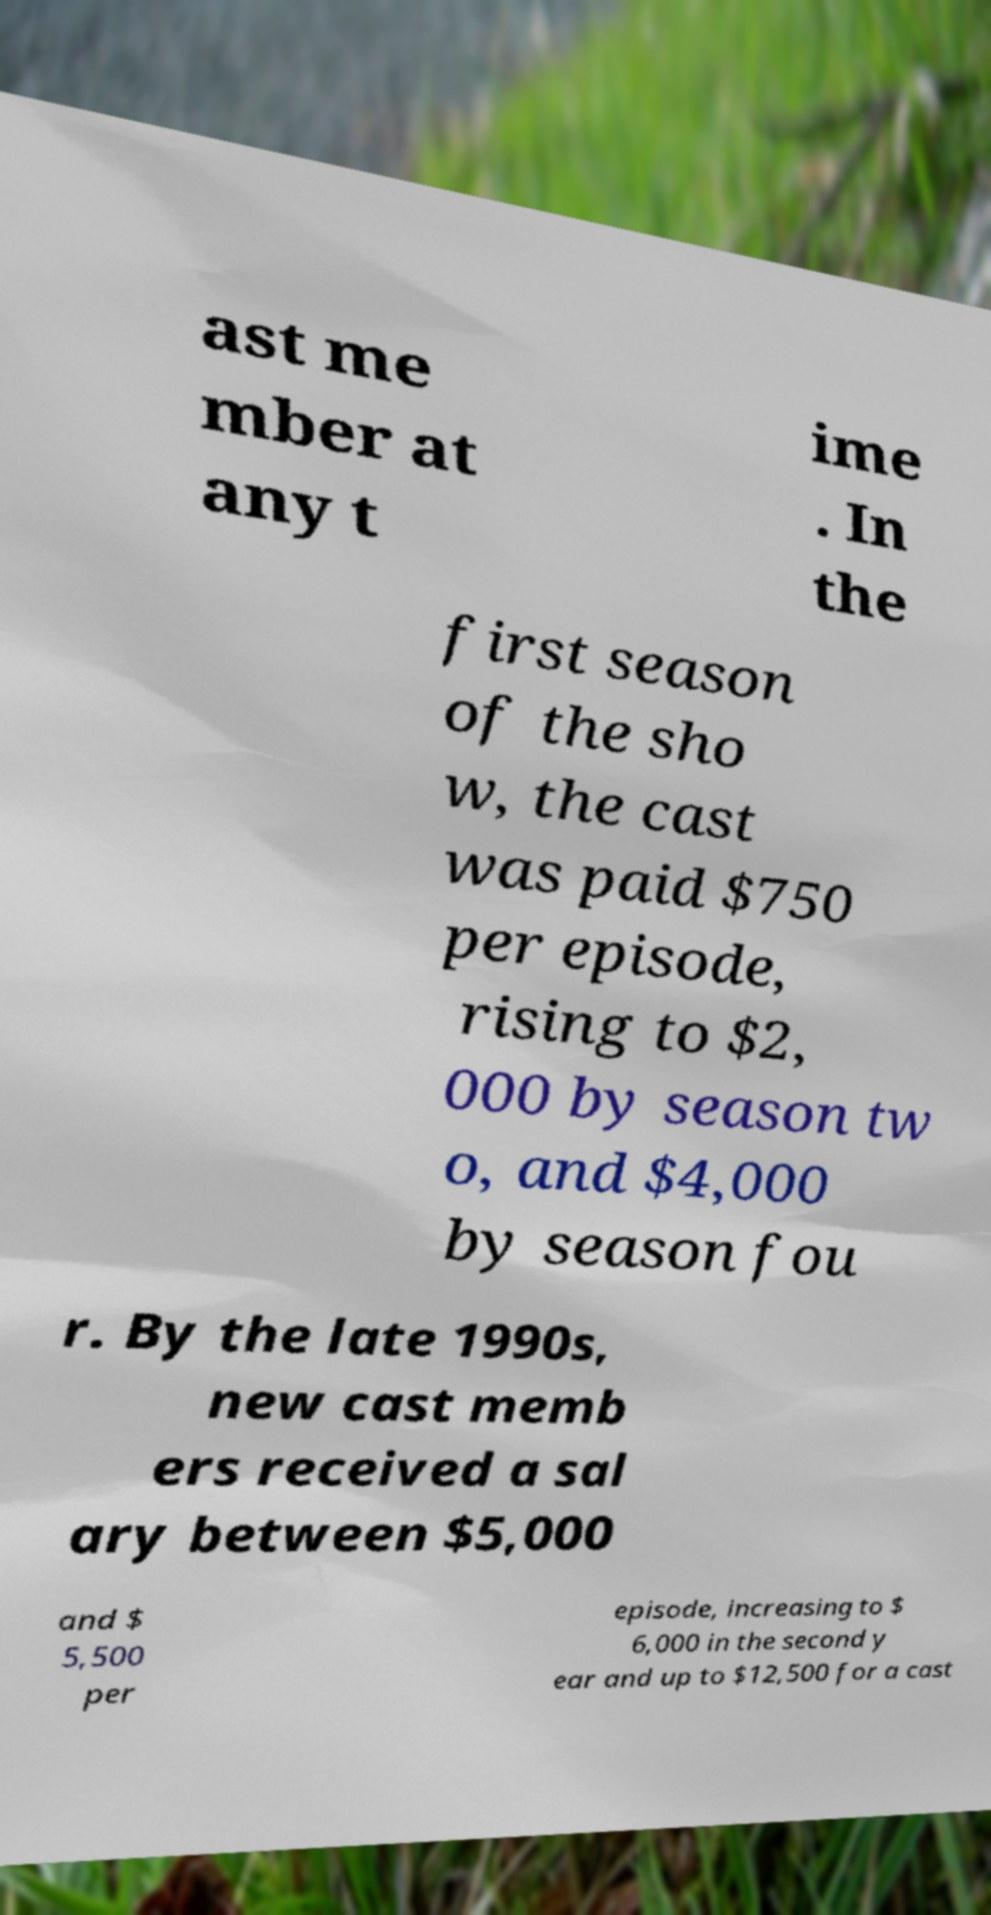Can you read and provide the text displayed in the image?This photo seems to have some interesting text. Can you extract and type it out for me? ast me mber at any t ime . In the first season of the sho w, the cast was paid $750 per episode, rising to $2, 000 by season tw o, and $4,000 by season fou r. By the late 1990s, new cast memb ers received a sal ary between $5,000 and $ 5,500 per episode, increasing to $ 6,000 in the second y ear and up to $12,500 for a cast 